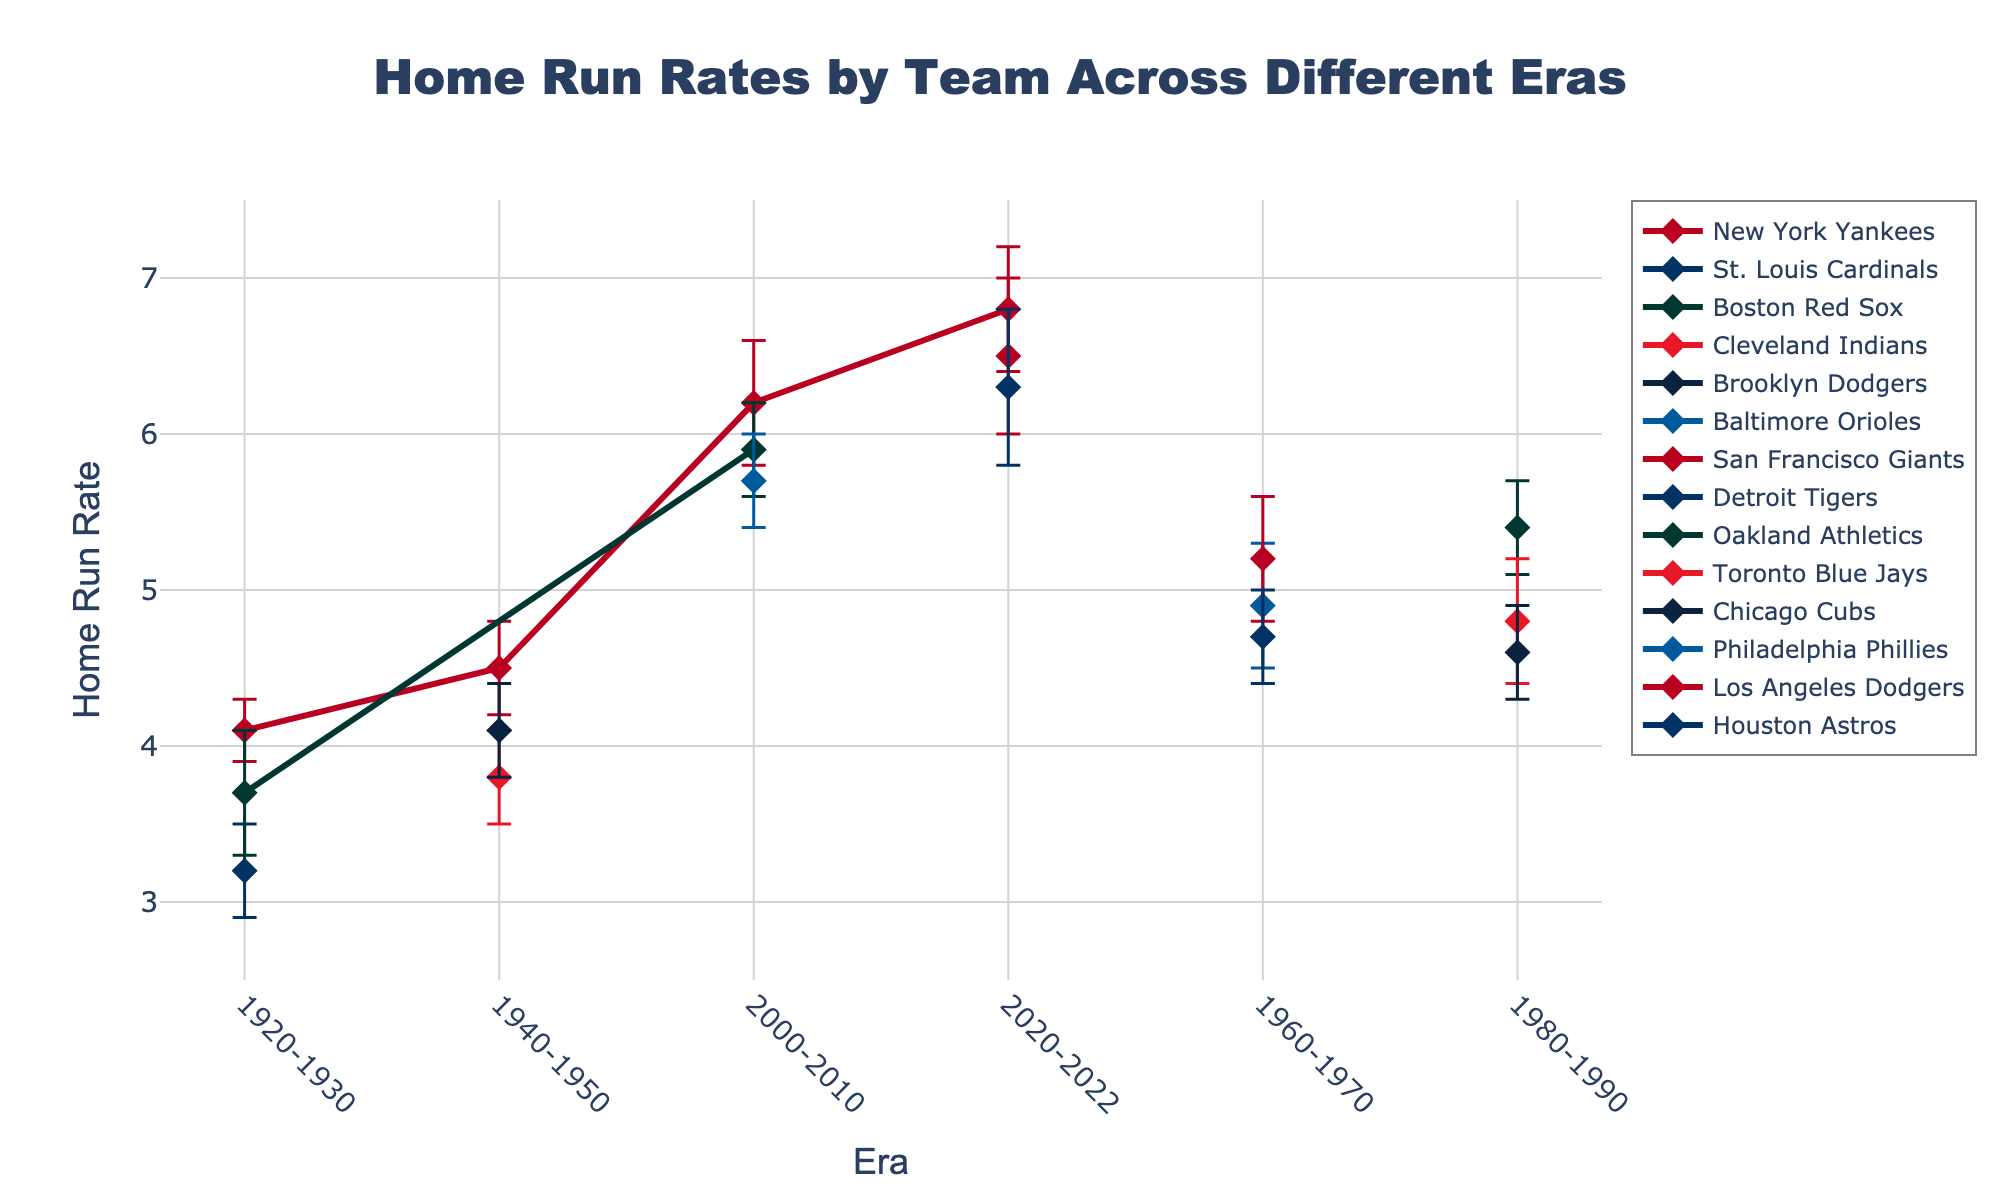Which era has the highest home run rate for the New York Yankees? The New York Yankees have data points in multiple eras. By comparing home run rates, the highest rate for the New York Yankees appears in the 2020-2022 era with a value of 6.8.
Answer: 2020-2022 Which team shows the widest error margin in the 1920-1930 era? By examining the error bars in the 1920-1930 era, the Boston Red Sox have the widest error margin of 0.4, compared to the New York Yankees with 0.2 and the St. Louis Cardinals with 0.3.
Answer: Boston Red Sox What is the overall trend of home run rates from the 1920-1930 era to the 2020-2022 era? Observing the general pattern across all team data points, there is an overall increasing trend in home run rates from the earlier era (1920-1930) to the latest era (2020-2022).
Answer: Increasing Among the teams listed, which one has the lowest home run rate in the 1980-1990 era, and what is the rate? In the 1980-1990 era, the team with the lowest home run rate is the Chicago Cubs with a rate of 4.6.
Answer: Chicago Cubs (4.6) Which era shows the highest variability in team home run rates based on the error margins? To determine the era with the highest variability, one can look at the length of the error bars. The 2020-2022 era shows the highest variability with error margins up to 0.5.
Answer: 2020-2022 How does the home run rate of the Boston Red Sox in the 2000-2010 era compare to their rate in the 1920-1930 era? The Boston Red Sox's home run rate increases from 3.7 in the 1920-1930 era to 5.9 in the 2000-2010 era.
Answer: Increased Which teams have consistent home run rates across different eras with minimal error margins? Teams with consistently low variation in their home run rates across eras, indicated by shorter error bars, include the Cleveland Indians and Brooklyn Dodgers in the 1940-1950 era, as both have error margins of 0.3.
Answer: Cleveland Indians, Brooklyn Dodgers What is the difference between the highest and lowest team home run rates in the 1960-1970 era? In the 1960-1970 era, the highest home run rate is 5.2 by the San Francisco Giants, and the lowest is 4.7 by the Detroit Tigers, resulting in a difference of 0.5.
Answer: 0.5 Between the New York Yankees and the Philadelphia Phillies in the 2000-2010 era, which team has a higher home run rate and by how much? In the 2000-2010 era, the New York Yankees have a home run rate of 6.2, while the Philadelphia Phillies have a rate of 5.7. The difference is 6.2 - 5.7 = 0.5.
Answer: New York Yankees by 0.5 